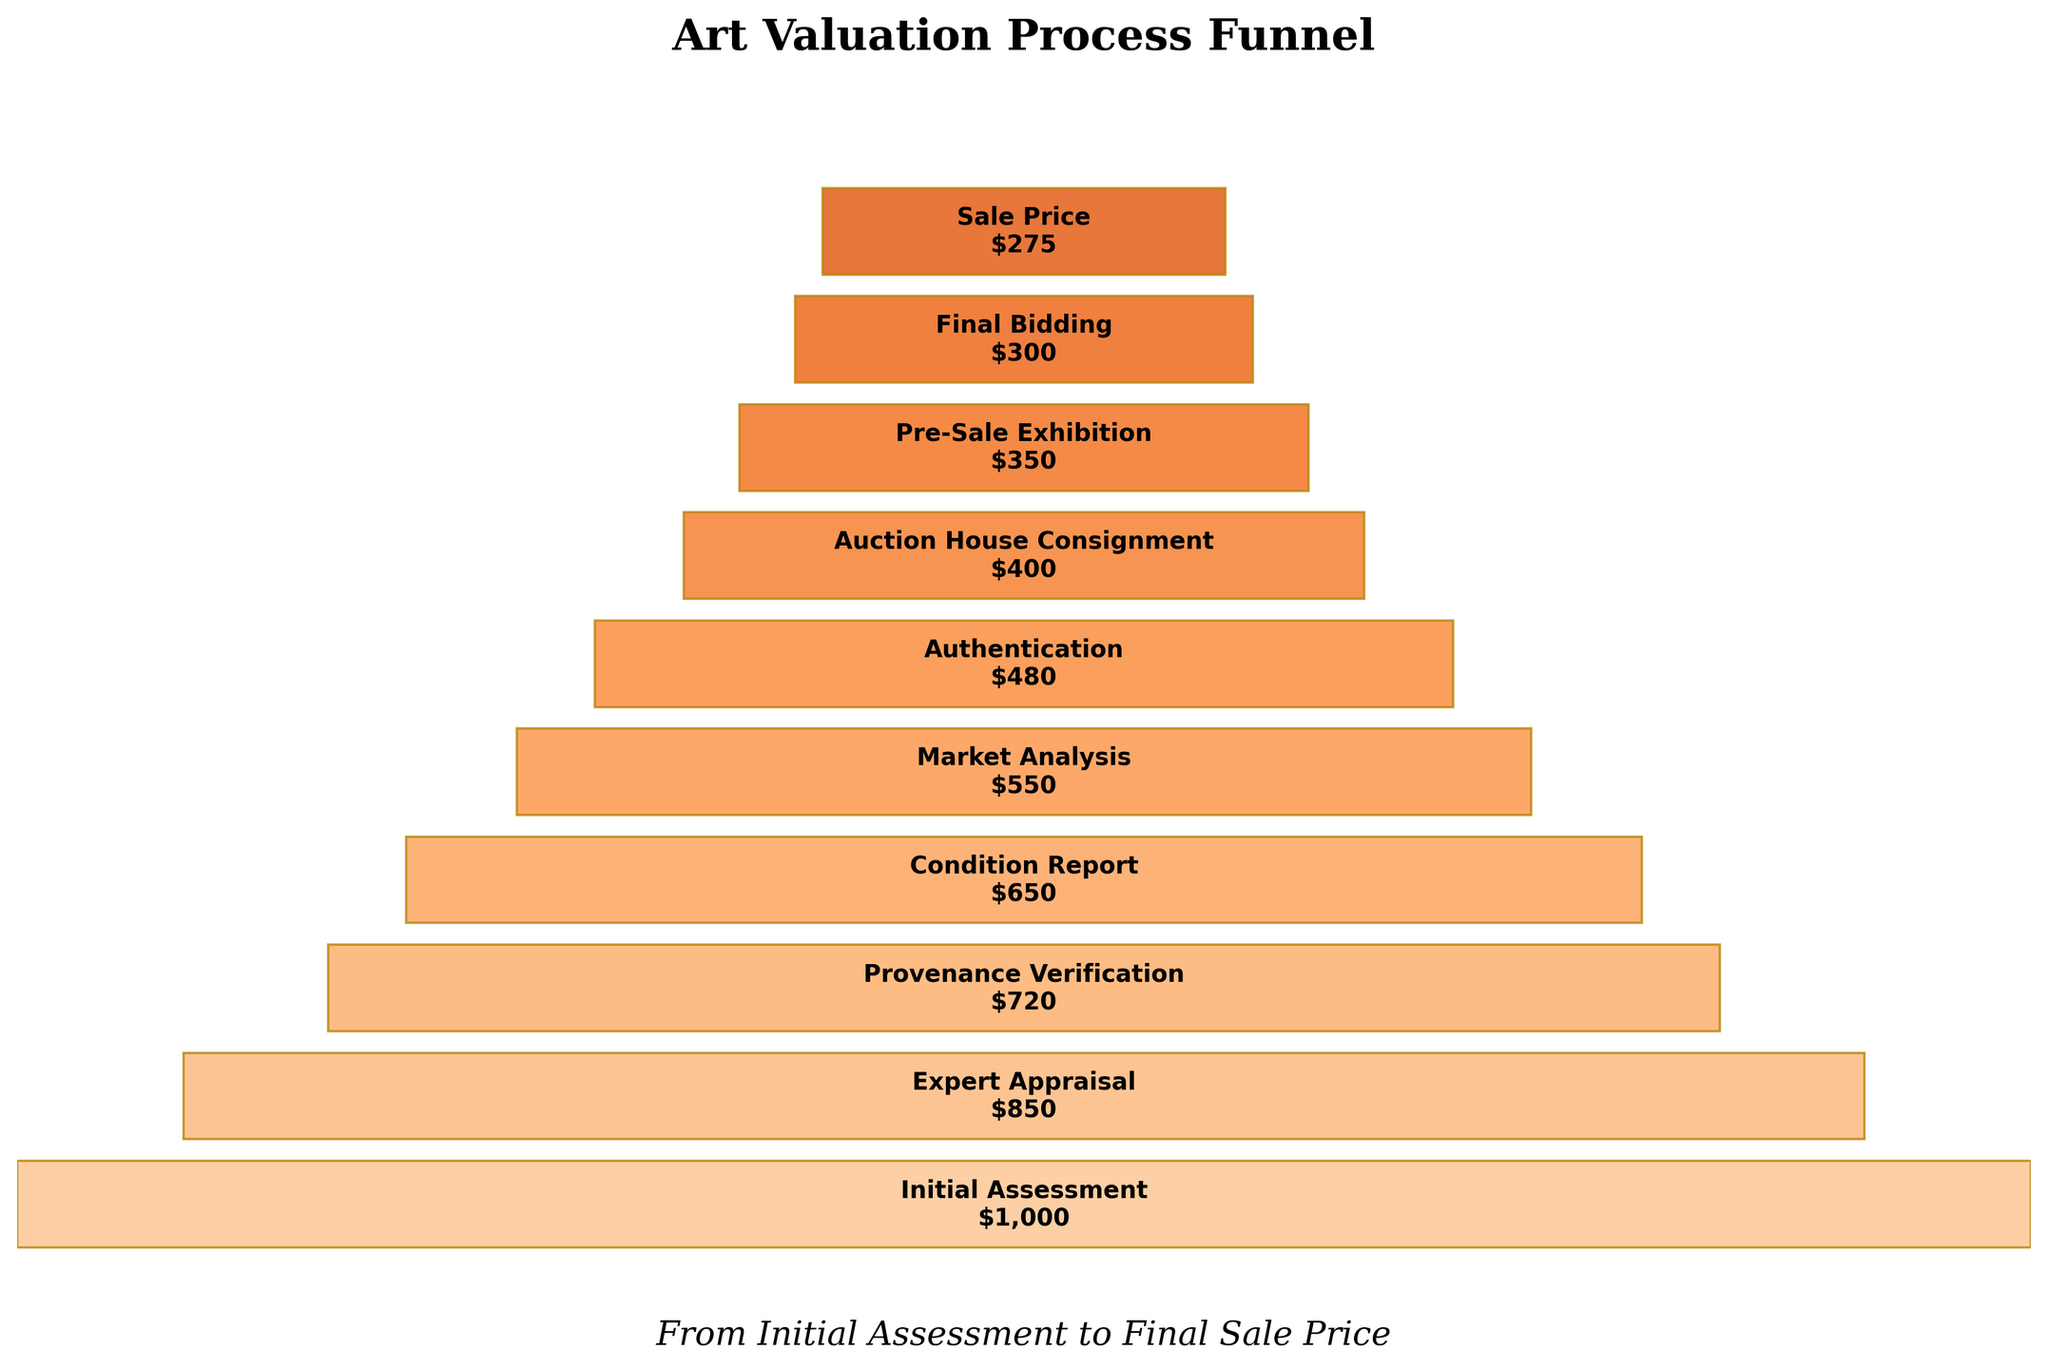What's the lowest value recorded in the funnel chart? Identify the smallest value segment in the chart, which corresponds to the Sale Price. The Sale Price segment shows a value of $275.
Answer: $275 Which step in the valuation process has a value of $650? Find the segment that corresponds to the value of $650. The Condition Report segment displays a value of $650.
Answer: Condition Report What is the total decrease in value from the Initial Assessment to Provenance Verification? Calculate the difference between the Initial Assessment and Provenance Verification values: $1000 - $720 = $280.
Answer: $280 How much value is lost between the Market Analysis and Auction House Consignment steps? Compute the difference between the values at Market Analysis and Auction House Consignment: $550 - $400 = $150.
Answer: $150 What percentage of the initial assessment value remains after the final bidding? Divide the Final Bidding value by the Initial Assessment value and multiply by 100: ($300 / $1000) * 100 = 30%.
Answer: 30% Which step experiences the largest single decrease in value? Compare the decreases between consecutive steps. The largest single decrease is from Initial Assessment ($1000) to Expert Appraisal ($850), a drop of $150.
Answer: Initial Assessment to Expert Appraisal How many steps have values greater than $500? Count the segments with values above $500: Initial Assessment, Expert Appraisal, Provenance Verification, Condition Report, and Market Analysis. There are 5 steps in total.
Answer: 5 What is the difference between the values at Provenance Verification and Authentication? Calculate the difference between the values at Provenance Verification ($720) and Authentication ($480): $720 - $480 = $240.
Answer: $240 Which step has the smallest value decrease compared to the previous step? Evaluate the value decreases between consecutive steps and find the smallest decrease. The smallest decrease is from Authentication ($480) to Auction House Consignment ($400), a drop of $80.
Answer: Authentication to Auction House Consignment In terms of absolute values, which step shows the midpoint in the valuation process? Locate the step closest to the middle of the sequence. The midpoint in terms of steps is shown by the Market Analysis with a value of $550.
Answer: Market Analysis 